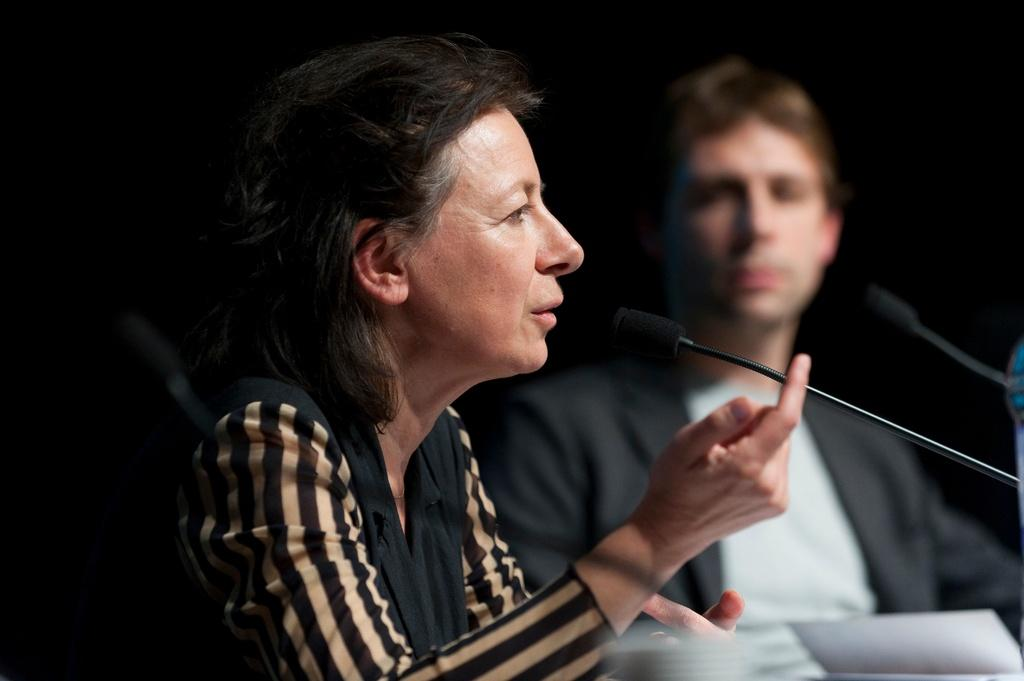Who are the people in the image? There is a man and a lady in the image. What objects are present in the image that might be used for communication? There are microphones (mics) in the image. What can be seen at the bottom of the image? There are papers at the bottom of the image. What type of music is being played in the image? There is no music present in the image; it only shows a man, a lady, microphones, and papers. 